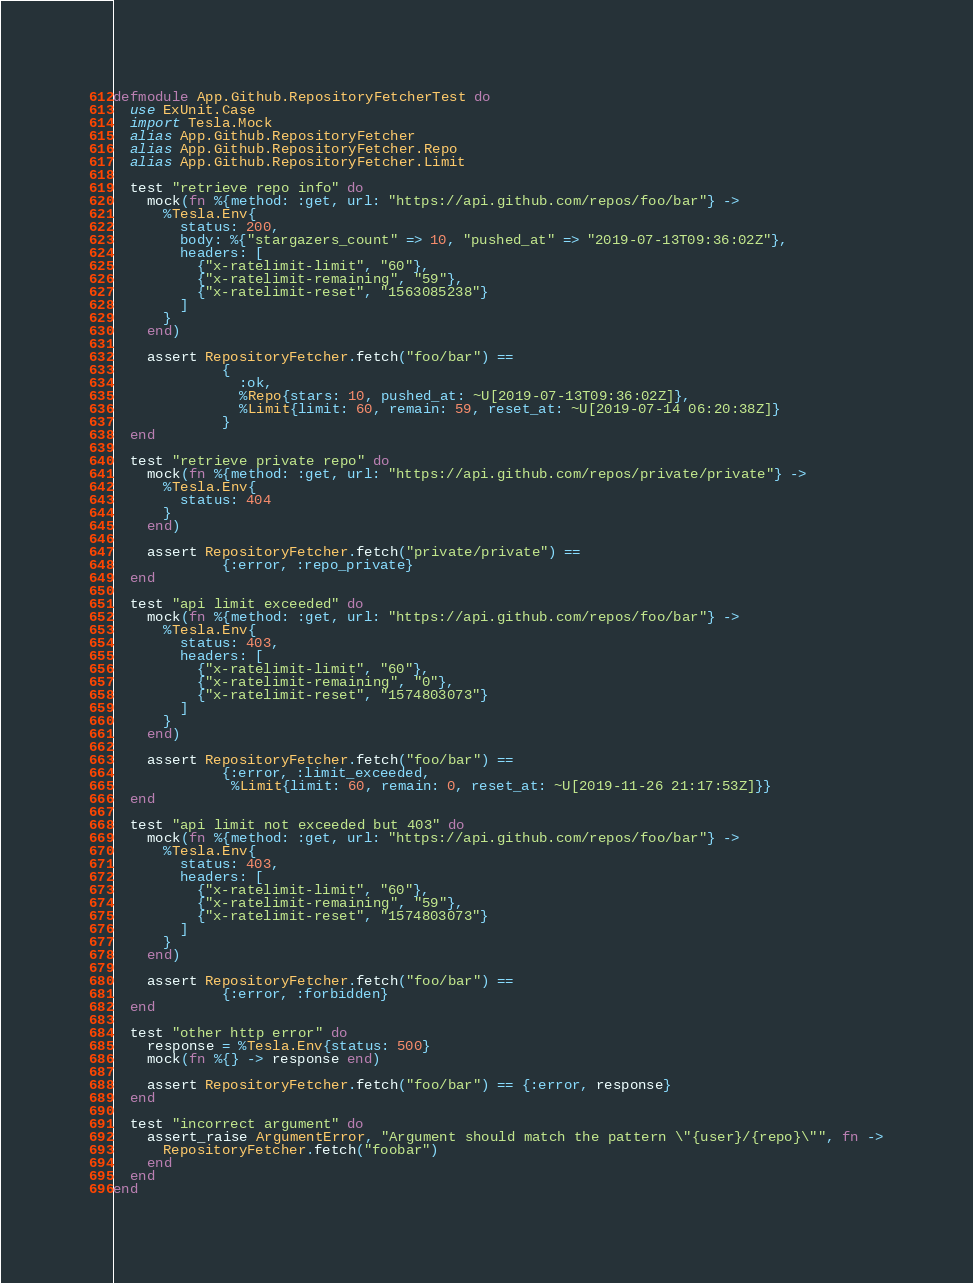<code> <loc_0><loc_0><loc_500><loc_500><_Elixir_>defmodule App.Github.RepositoryFetcherTest do
  use ExUnit.Case
  import Tesla.Mock
  alias App.Github.RepositoryFetcher
  alias App.Github.RepositoryFetcher.Repo
  alias App.Github.RepositoryFetcher.Limit

  test "retrieve repo info" do
    mock(fn %{method: :get, url: "https://api.github.com/repos/foo/bar"} ->
      %Tesla.Env{
        status: 200,
        body: %{"stargazers_count" => 10, "pushed_at" => "2019-07-13T09:36:02Z"},
        headers: [
          {"x-ratelimit-limit", "60"},
          {"x-ratelimit-remaining", "59"},
          {"x-ratelimit-reset", "1563085238"}
        ]
      }
    end)

    assert RepositoryFetcher.fetch("foo/bar") ==
             {
               :ok,
               %Repo{stars: 10, pushed_at: ~U[2019-07-13T09:36:02Z]},
               %Limit{limit: 60, remain: 59, reset_at: ~U[2019-07-14 06:20:38Z]}
             }
  end

  test "retrieve private repo" do
    mock(fn %{method: :get, url: "https://api.github.com/repos/private/private"} ->
      %Tesla.Env{
        status: 404
      }
    end)

    assert RepositoryFetcher.fetch("private/private") ==
             {:error, :repo_private}
  end

  test "api limit exceeded" do
    mock(fn %{method: :get, url: "https://api.github.com/repos/foo/bar"} ->
      %Tesla.Env{
        status: 403,
        headers: [
          {"x-ratelimit-limit", "60"},
          {"x-ratelimit-remaining", "0"},
          {"x-ratelimit-reset", "1574803073"}
        ]
      }
    end)

    assert RepositoryFetcher.fetch("foo/bar") ==
             {:error, :limit_exceeded,
              %Limit{limit: 60, remain: 0, reset_at: ~U[2019-11-26 21:17:53Z]}}
  end

  test "api limit not exceeded but 403" do
    mock(fn %{method: :get, url: "https://api.github.com/repos/foo/bar"} ->
      %Tesla.Env{
        status: 403,
        headers: [
          {"x-ratelimit-limit", "60"},
          {"x-ratelimit-remaining", "59"},
          {"x-ratelimit-reset", "1574803073"}
        ]
      }
    end)

    assert RepositoryFetcher.fetch("foo/bar") ==
             {:error, :forbidden}
  end

  test "other http error" do
    response = %Tesla.Env{status: 500}
    mock(fn %{} -> response end)

    assert RepositoryFetcher.fetch("foo/bar") == {:error, response}
  end

  test "incorrect argument" do
    assert_raise ArgumentError, "Argument should match the pattern \"{user}/{repo}\"", fn ->
      RepositoryFetcher.fetch("foobar")
    end
  end
end
</code> 